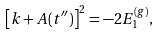<formula> <loc_0><loc_0><loc_500><loc_500>\left [ k + A ( t ^ { \prime \prime } ) \right ] ^ { 2 } = - 2 E _ { 1 } ^ { ( g ) } ,</formula> 